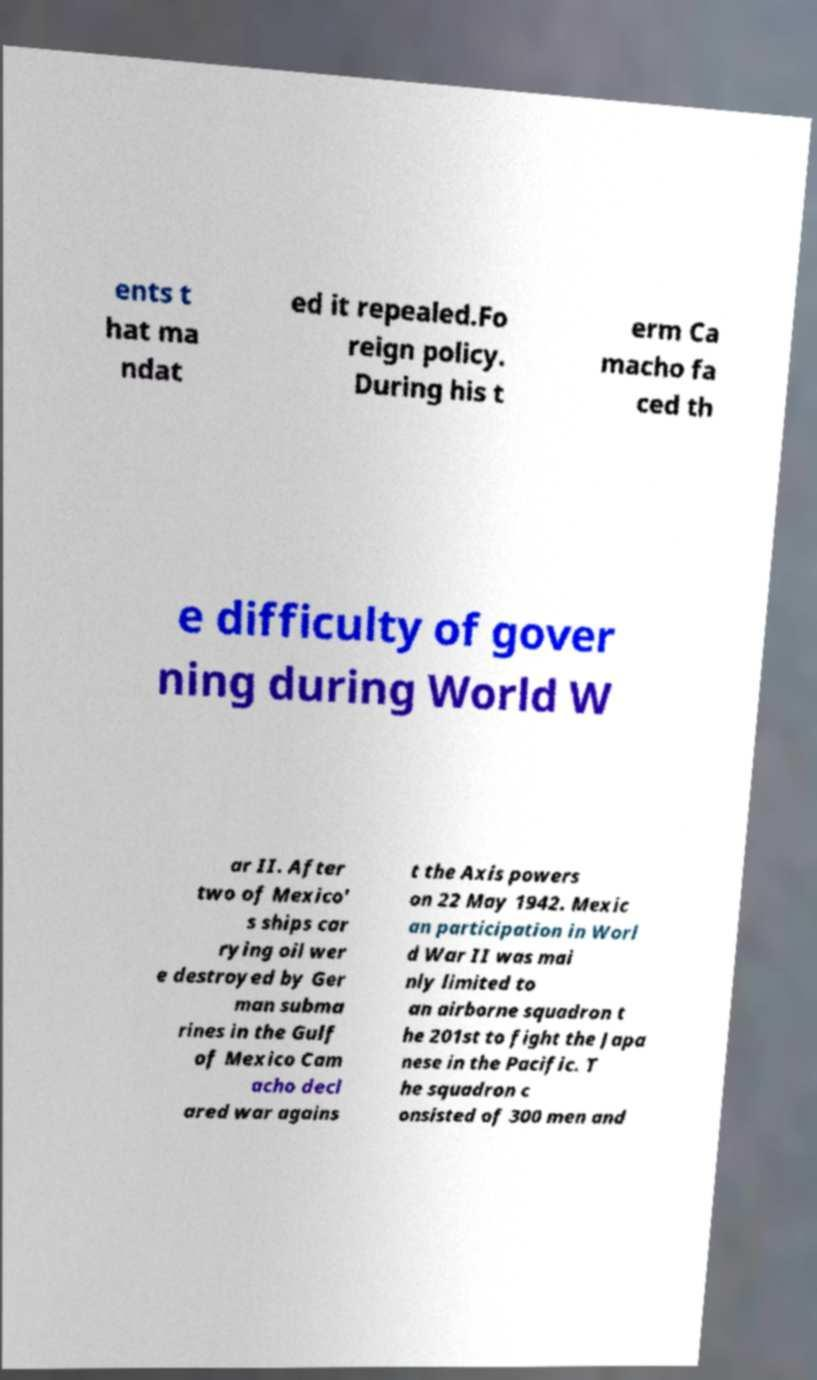For documentation purposes, I need the text within this image transcribed. Could you provide that? ents t hat ma ndat ed it repealed.Fo reign policy. During his t erm Ca macho fa ced th e difficulty of gover ning during World W ar II. After two of Mexico' s ships car rying oil wer e destroyed by Ger man subma rines in the Gulf of Mexico Cam acho decl ared war agains t the Axis powers on 22 May 1942. Mexic an participation in Worl d War II was mai nly limited to an airborne squadron t he 201st to fight the Japa nese in the Pacific. T he squadron c onsisted of 300 men and 